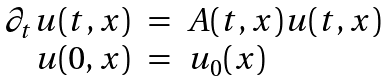<formula> <loc_0><loc_0><loc_500><loc_500>\begin{array} { r c l } \partial _ { t } u ( t , x ) & = & A ( t , x ) u ( t , x ) \\ u ( 0 , x ) & = & u _ { 0 } ( x ) \end{array}</formula> 